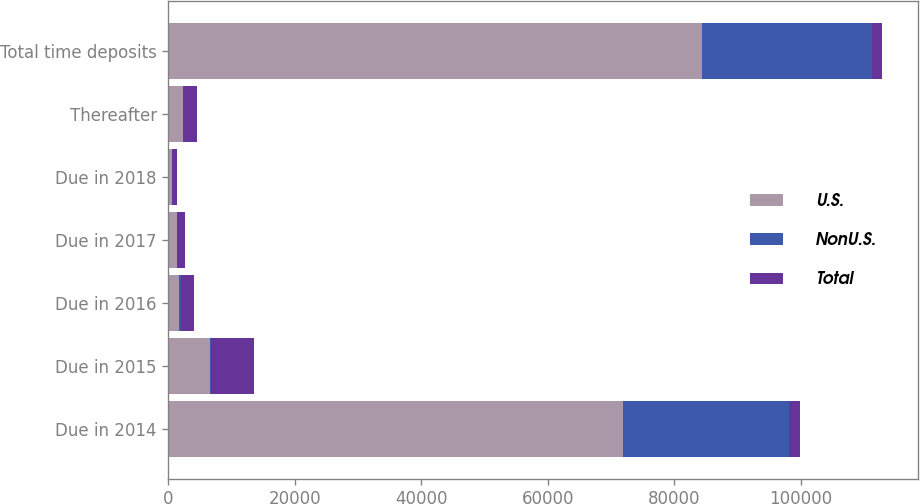Convert chart to OTSL. <chart><loc_0><loc_0><loc_500><loc_500><stacked_bar_chart><ecel><fcel>Due in 2014<fcel>Due in 2015<fcel>Due in 2016<fcel>Due in 2017<fcel>Due in 2018<fcel>Thereafter<fcel>Total time deposits<nl><fcel>U.S.<fcel>71895<fcel>6523<fcel>1719<fcel>1308<fcel>649<fcel>2274<fcel>84368<nl><fcel>NonU.S.<fcel>26306<fcel>227<fcel>315<fcel>14<fcel>1<fcel>4<fcel>26867<nl><fcel>Total<fcel>1719<fcel>6750<fcel>2034<fcel>1322<fcel>650<fcel>2278<fcel>1719<nl></chart> 